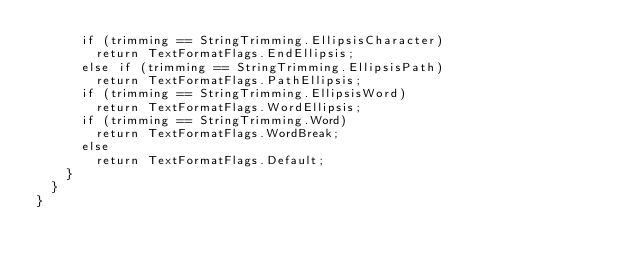Convert code to text. <code><loc_0><loc_0><loc_500><loc_500><_C#_>			if (trimming == StringTrimming.EllipsisCharacter)
				return TextFormatFlags.EndEllipsis;
			else if (trimming == StringTrimming.EllipsisPath)
				return TextFormatFlags.PathEllipsis;
			if (trimming == StringTrimming.EllipsisWord)
				return TextFormatFlags.WordEllipsis;
			if (trimming == StringTrimming.Word)
				return TextFormatFlags.WordBreak;
			else
				return TextFormatFlags.Default;
		}
	}
}
</code> 